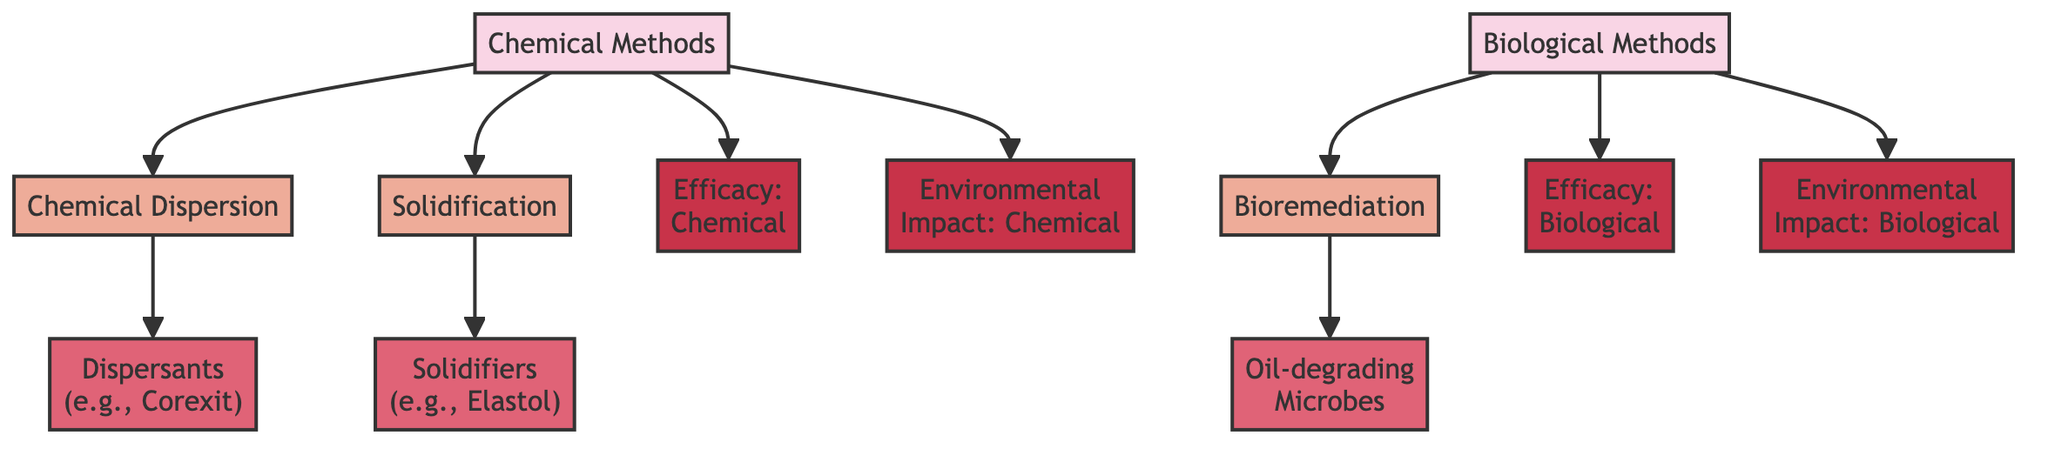What are the three types of chemical methods listed? The diagram shows two main categories: Chemical Methods and Biological Methods. Under Chemical Methods, there are three specific methods mentioned: Chemical Dispersion, Solidification, and Bioremediation. Therefore, the answer can be found by checking the nodes listed under Chemical Methods.
Answer: Chemical Dispersion, Solidification, Bioremediation How many specific methods are described for chemical methods? The Chemical Methods category is connected to three specific methods: Chemical Dispersion, Solidification, and Bioremediation. Therefore, we count the connecting arrows from the Chemical Methods node to determine how many specific methods are mentioned.
Answer: 3 What type of agent is associated with solidification? The solidification method connects to the Solidifiers agent node. By tracing the flow from Solidification to its associated agent, we can identify what type of agent it represents.
Answer: Solidifiers What is the environmental impact associated with chemical methods? The Chemical Methods node directly connects to the Environmental Impact: Chemical node. To answer this, we look at the connections that show the evaluation aspects of the chemical methods.
Answer: Environmental Impact: Chemical Which method involves microbes? The bioremediation method connects to the Oil-degrading Microbes agent. By following the connection from the Biological Methods node to its associated method, we identify that it specifically involves microbes.
Answer: Bioremediation What type of chemical dispersant is mentioned in the diagram? The dispersion method connects to the Dispersants agent node, which includes an example in the text. By locating the agent associated with Chemical Dispersion, we can specify the exact chemical dispersant.
Answer: Corexit Which method has a stronger environmental impact according to the diagram? To address this, we evaluate the arrows leading from the Chemical Methods and Biological Methods to their respective environmental impact nodes. Both methods have an impact node, and they can be compared to see which one is notably referenced or highlighted. Given the diagram points, we note the lack of stronger emphasis on one over the other and conclude both methods are evaluated independently.
Answer: Not specified How many types of biological methods are listed? In the diagram, there is one category labeled Biological Methods, which is linked to only one specific method, which is Bioremediation. By counting how many specific methods link from Biological Methods node, we can determine the number of methods available.
Answer: 1 What does the efficacy evaluation for biological methods refer to? The diagram connects Biological Methods to the Efficacy: Biological evaluation node. Therefore, by examining this path from Biological Methods, we can grasp that it assesses the effectiveness of the biological methods in cleaning oil spills.
Answer: Efficacy: Biological 